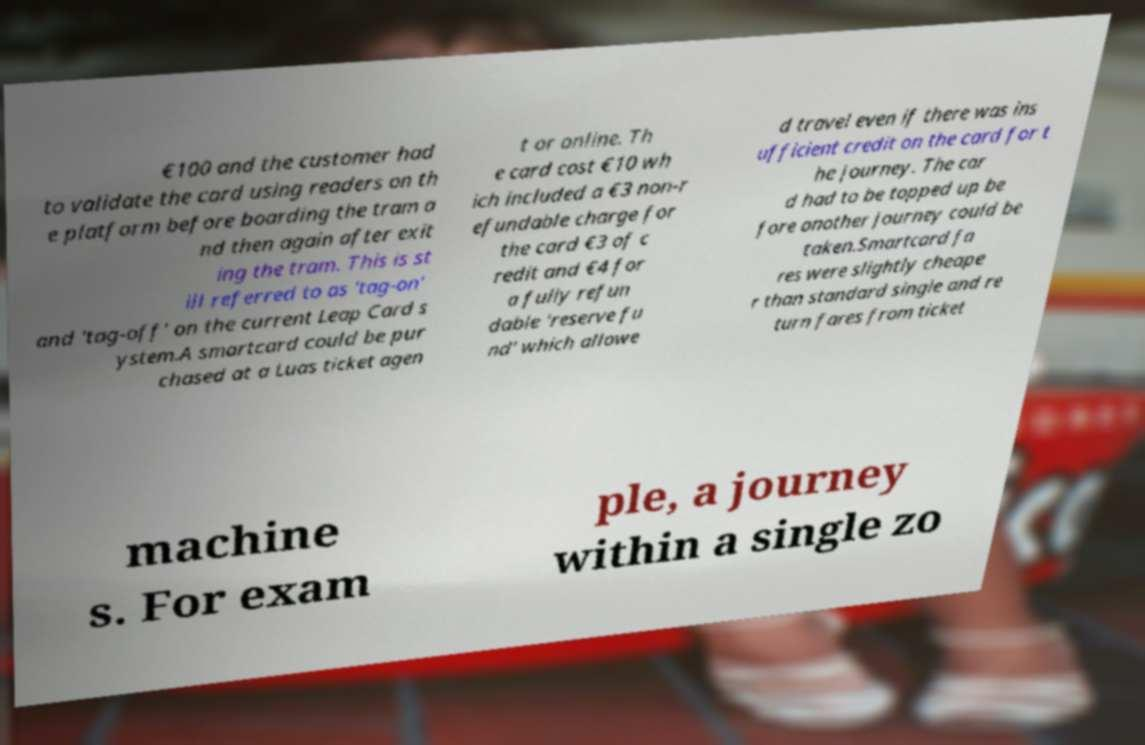Can you read and provide the text displayed in the image?This photo seems to have some interesting text. Can you extract and type it out for me? €100 and the customer had to validate the card using readers on th e platform before boarding the tram a nd then again after exit ing the tram. This is st ill referred to as 'tag-on' and 'tag-off' on the current Leap Card s ystem.A smartcard could be pur chased at a Luas ticket agen t or online. Th e card cost €10 wh ich included a €3 non-r efundable charge for the card €3 of c redit and €4 for a fully refun dable 'reserve fu nd' which allowe d travel even if there was ins ufficient credit on the card for t he journey. The car d had to be topped up be fore another journey could be taken.Smartcard fa res were slightly cheape r than standard single and re turn fares from ticket machine s. For exam ple, a journey within a single zo 